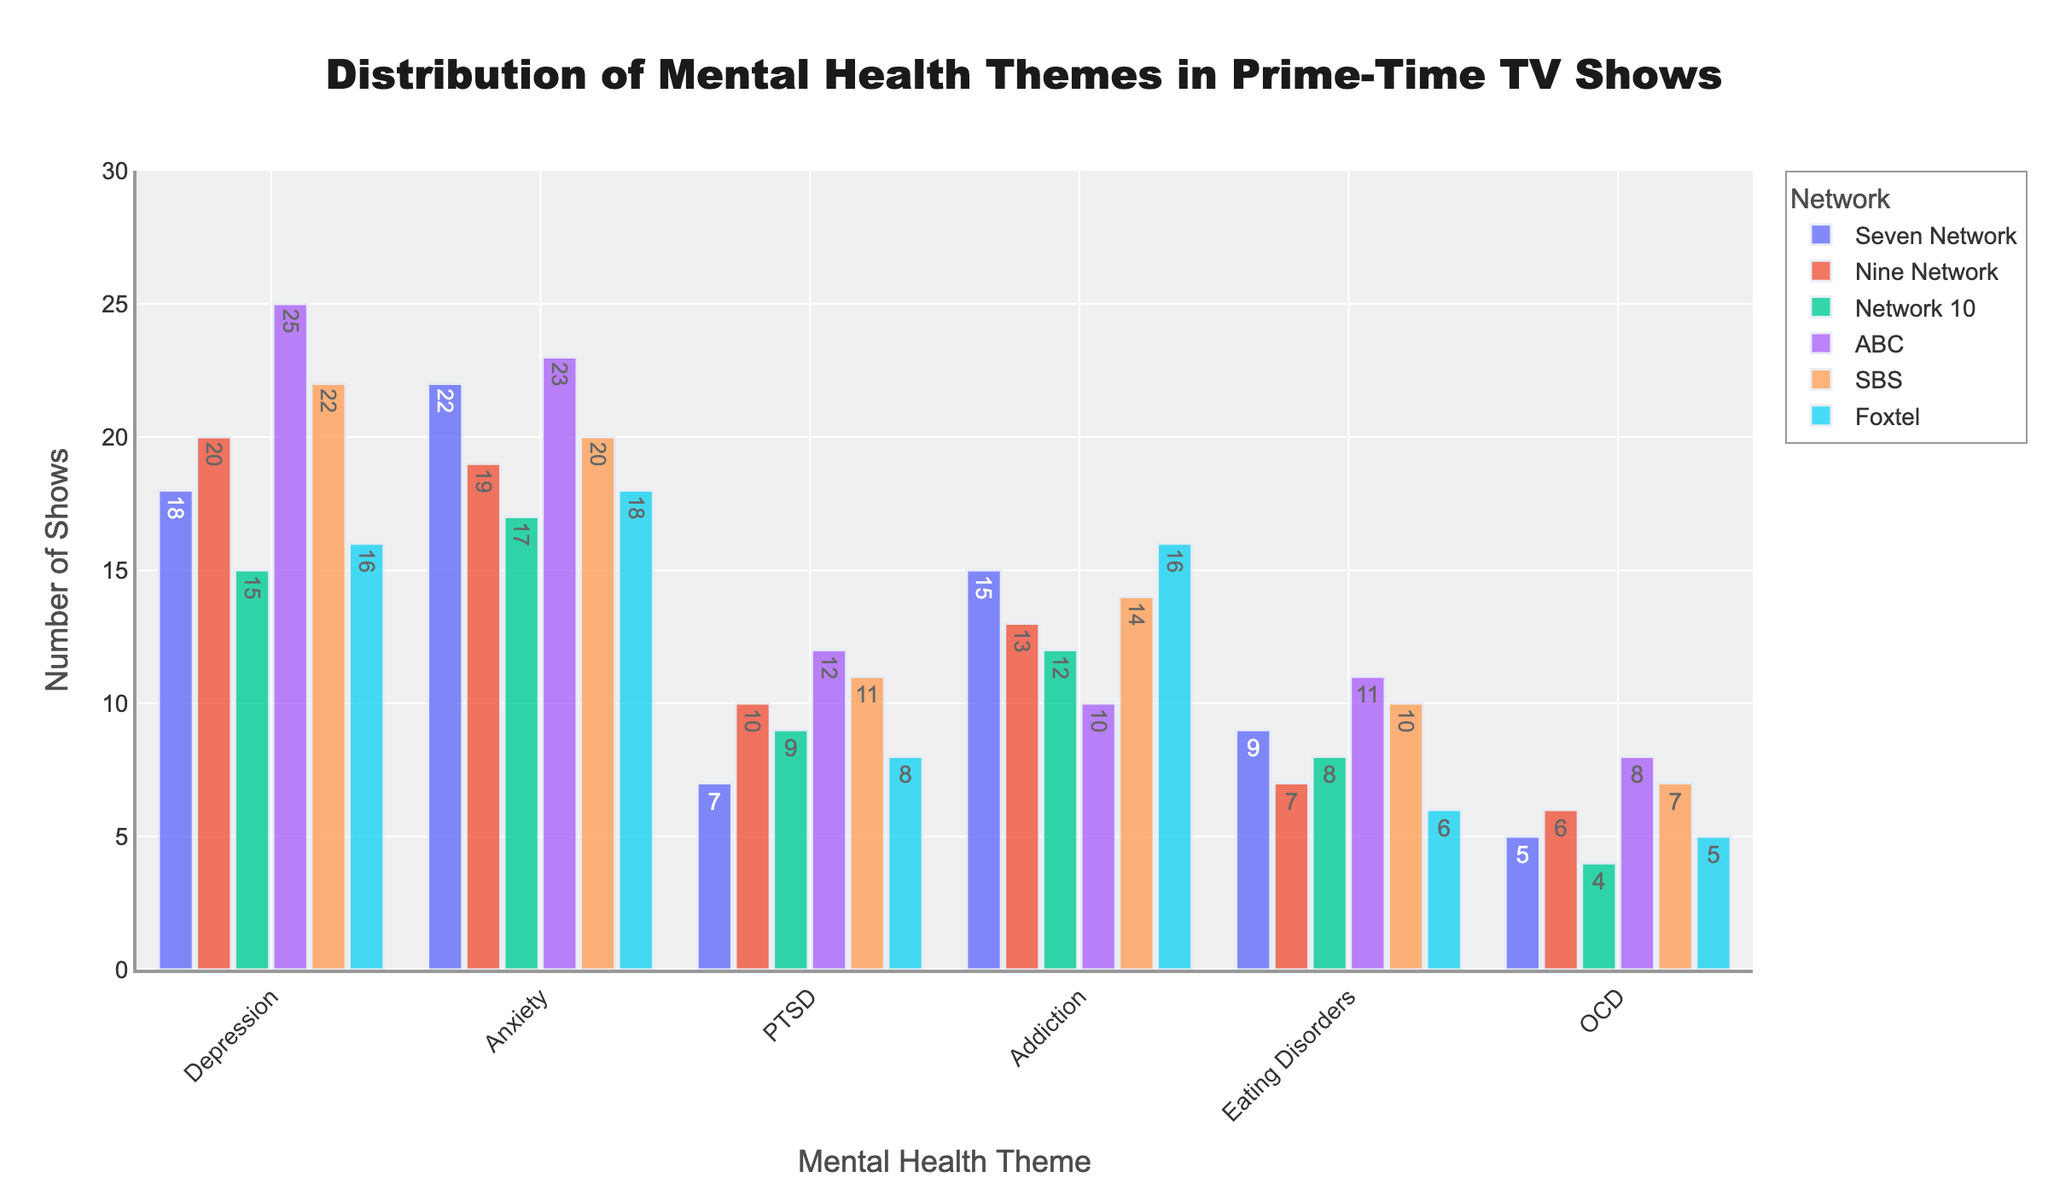Which network features the most shows addressing depression? To find the answer, look at the bars representing depression for each network. The ABC network has the highest bar at 25.
Answer: ABC How many shows in total discuss PTSD across all networks? Sum the number of shows discussing PTSD for each network. The counts are 7 (Seven Network), 10 (Nine Network), 9 (Network 10), 12 (ABC), 11 (SBS), and 8 (Foxtel). So, 7 + 10 + 9 + 12 + 11 + 8 = 57.
Answer: 57 Which mental health theme is depicted least frequently by Network 10? For Network 10, compare the bars for all mental health themes: 15 (Depression), 17 (Anxiety), 9 (PTSD), 12 (Addiction), 8 (Eating Disorders), and 4 (OCD). The smallest bar corresponds to OCD with 4 shows.
Answer: OCD Does SBS address addiction more frequently than Foxtel? Compare the bars labeled "Addiction" for both SBS and Foxtel: SBS has a bar height of 14, while Foxtel's is 16. Thus, Foxtel has more shows about addiction.
Answer: No Which two networks have the closest count of shows discussing anxiety? Compare the height of the anxiety bars across networks: Seven Network (22), Nine Network (19), Network 10 (17), ABC (23), SBS (20), Foxtel (18). The closest counts are for SBS and Nine Network, 20 and 19 respectively.
Answer: Nine Network and SBS What is the average number of shows discussing eating disorders across all networks? Sum the number of shows discussing eating disorders for each network: 9 (Seven Network), 7 (Nine Network), 8 (Network 10), 11 (ABC), 10 (SBS), 6 (Foxtel). The total is 9 + 7 + 8 + 11 + 10 + 6 = 51. Divide by the number of networks (6), so 51 / 6 = 8.5.
Answer: 8.5 How much higher is ABC's count of shows discussing depression compared to Network 10? Compare the "Depression" bars for ABC (25) and Network 10 (15). Calculate the difference: 25 - 15 = 10.
Answer: 10 Which network has the widest range of counts across all mental health themes? Calculate the range (difference between the highest and lowest count) for each network: Seven Network (22 - 5 = 17), Nine Network (20 - 6 = 14), Network 10 (17 - 4 = 13), ABC (25 - 8 = 17), SBS (22 - 7 = 15), Foxtel (18 - 5 = 13). The widest range is for Seven Network and ABC, both at 17.
Answer: Seven Network and ABC 